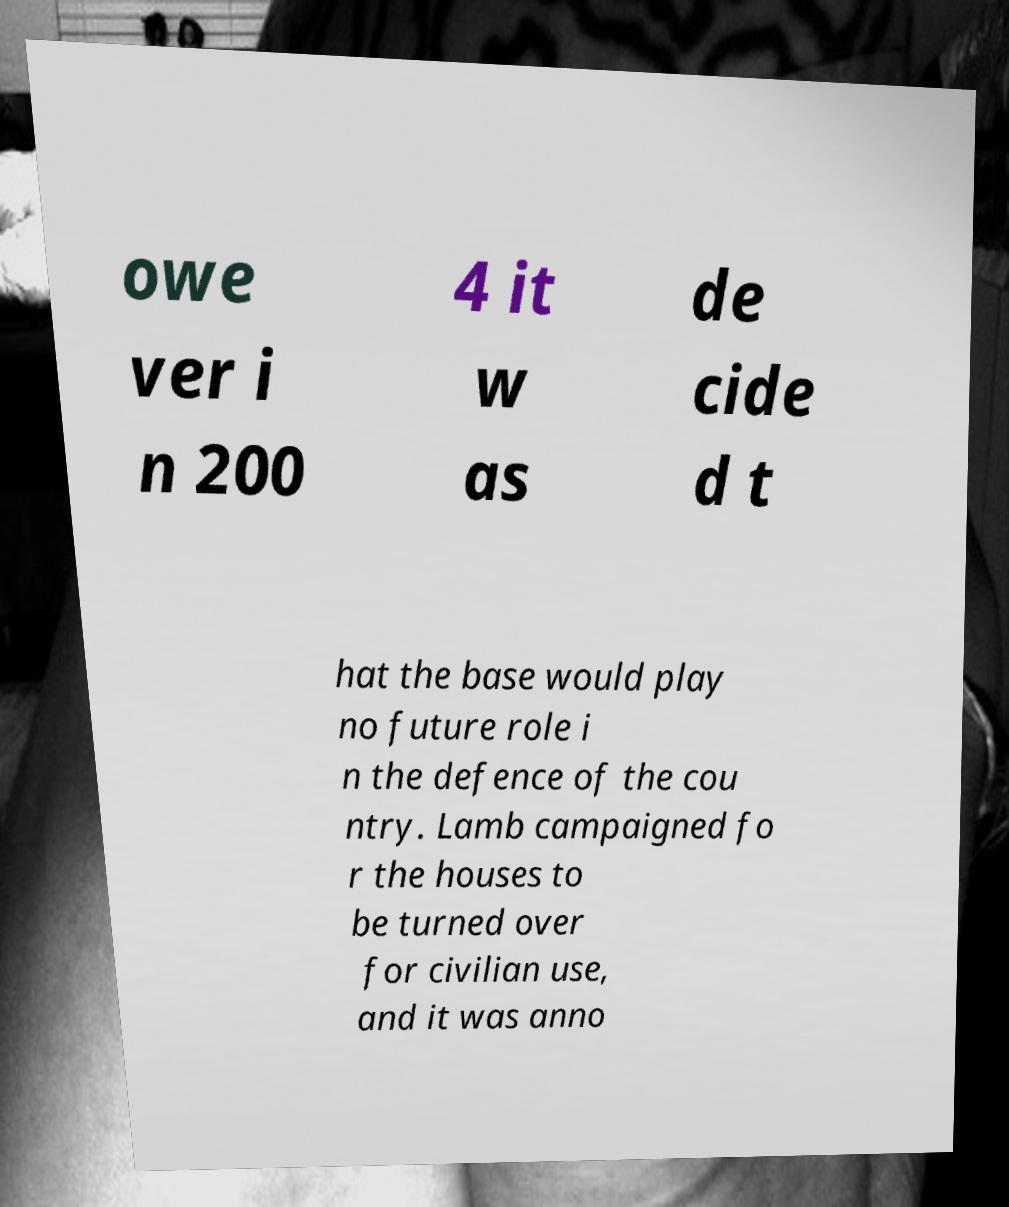Please identify and transcribe the text found in this image. owe ver i n 200 4 it w as de cide d t hat the base would play no future role i n the defence of the cou ntry. Lamb campaigned fo r the houses to be turned over for civilian use, and it was anno 